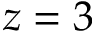<formula> <loc_0><loc_0><loc_500><loc_500>z = 3</formula> 